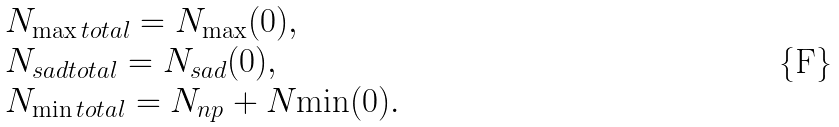<formula> <loc_0><loc_0><loc_500><loc_500>\begin{array} { l } N _ { \max t o t a l } = N _ { \max } ( 0 ) , \\ N _ { s a d t o t a l } = N _ { s a d } ( 0 ) , \\ N _ { \min t o t a l } = N _ { n p } + N { \min } ( 0 ) . \end{array}</formula> 